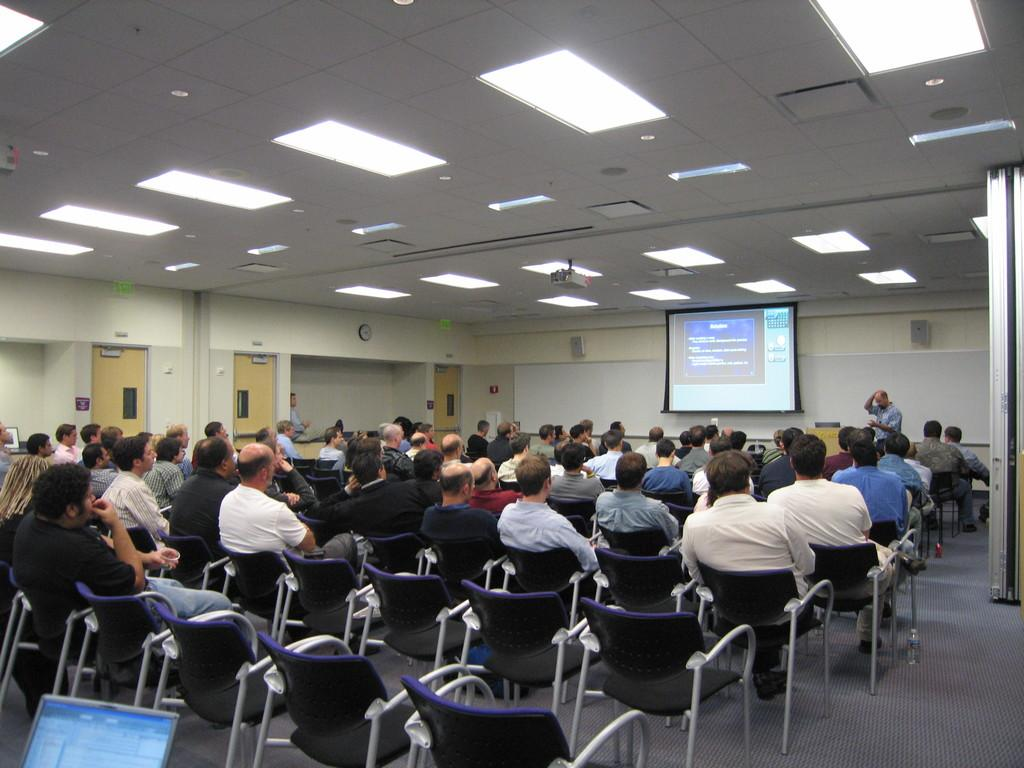How many people are in the image? There is a group of people in the image. What are the people in the image doing? The people are sitting in chairs. What object can be seen in front of the group of people? There is a projector in the image. Is there anyone near the projector? Yes, there is a person beside the projector. What type of ship can be seen in the image? There is no ship present in the image. What color is the sweater worn by the person beside the projector? We cannot determine the color of the sweater worn by the person beside the projector, as the image does not provide that information. 